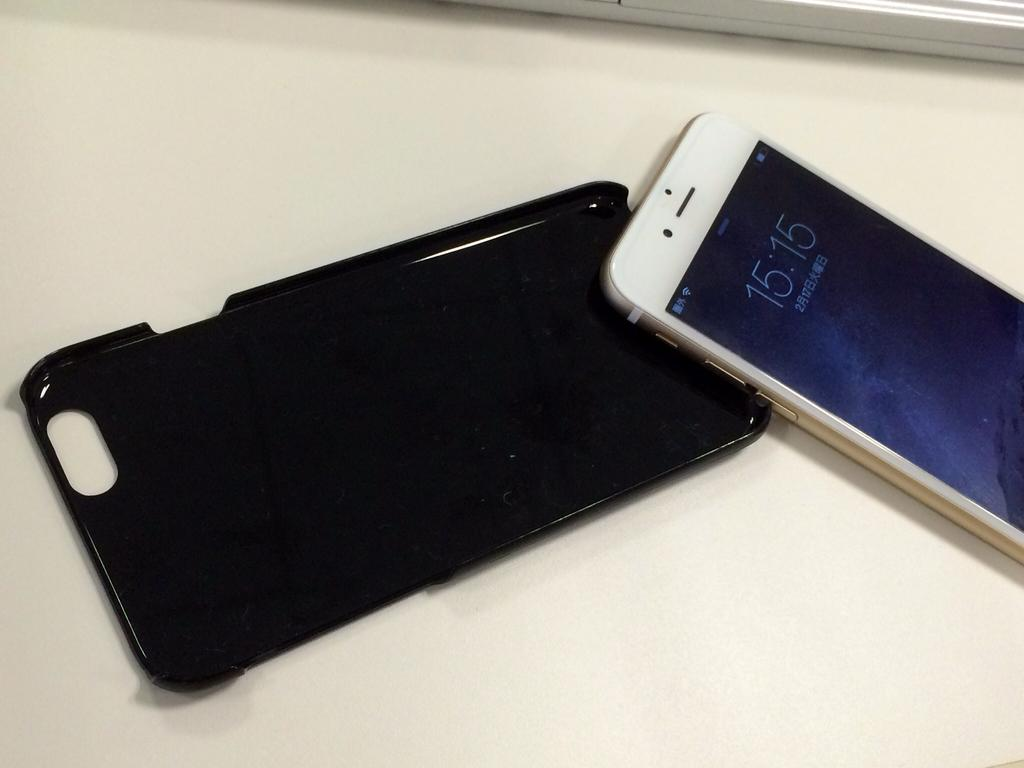<image>
Provide a brief description of the given image. A smart phone out of its case that shows time as 15:15. 